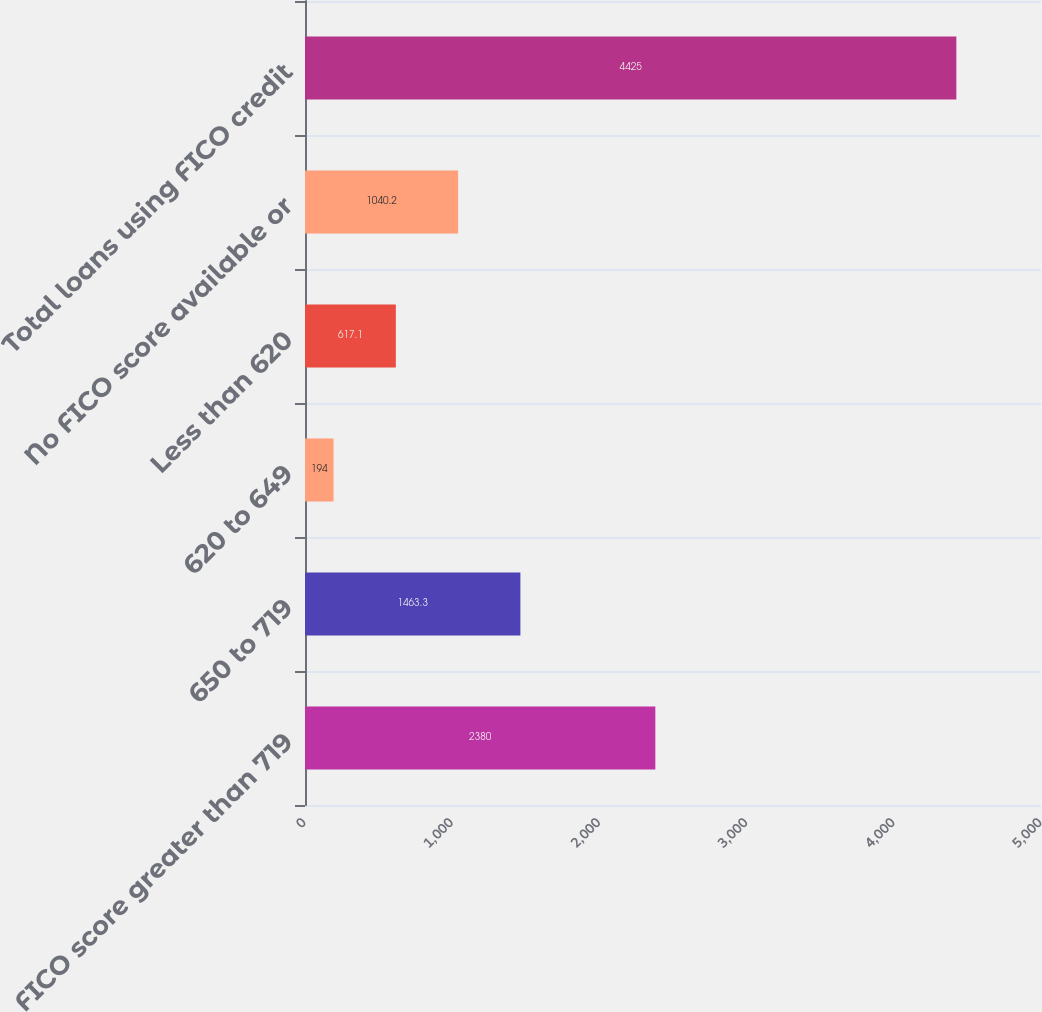Convert chart. <chart><loc_0><loc_0><loc_500><loc_500><bar_chart><fcel>FICO score greater than 719<fcel>650 to 719<fcel>620 to 649<fcel>Less than 620<fcel>No FICO score available or<fcel>Total loans using FICO credit<nl><fcel>2380<fcel>1463.3<fcel>194<fcel>617.1<fcel>1040.2<fcel>4425<nl></chart> 